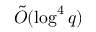Convert formula to latex. <formula><loc_0><loc_0><loc_500><loc_500>{ \tilde { O } } ( \log ^ { 4 } q )</formula> 